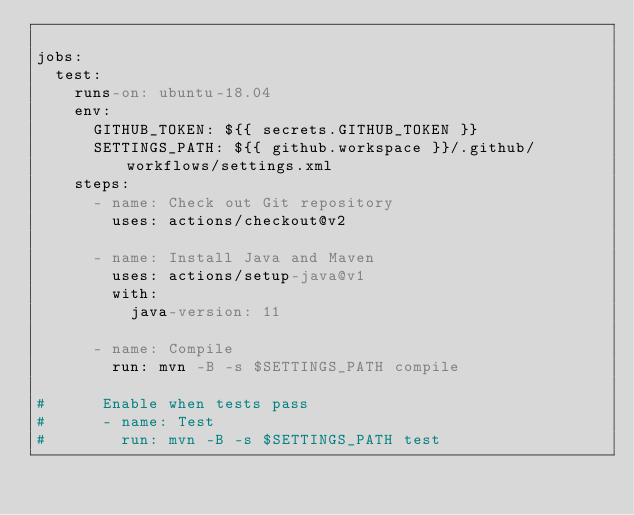Convert code to text. <code><loc_0><loc_0><loc_500><loc_500><_YAML_>
jobs:
  test:
    runs-on: ubuntu-18.04
    env: 
      GITHUB_TOKEN: ${{ secrets.GITHUB_TOKEN }}
      SETTINGS_PATH: ${{ github.workspace }}/.github/workflows/settings.xml
    steps:
      - name: Check out Git repository
        uses: actions/checkout@v2

      - name: Install Java and Maven
        uses: actions/setup-java@v1
        with:
          java-version: 11
          
      - name: Compile
        run: mvn -B -s $SETTINGS_PATH compile 

#      Enable when tests pass
#      - name: Test
#        run: mvn -B -s $SETTINGS_PATH test

</code> 